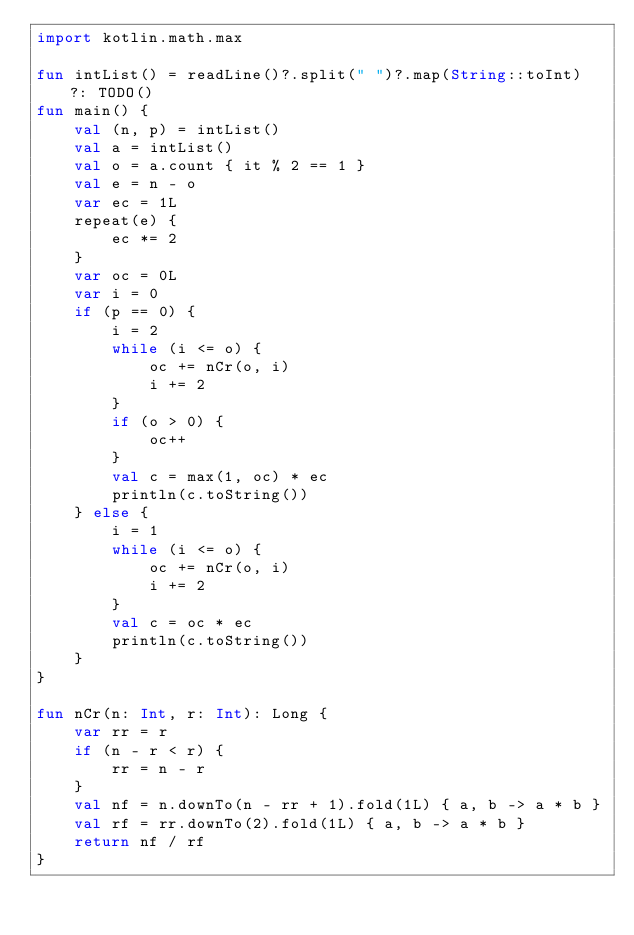Convert code to text. <code><loc_0><loc_0><loc_500><loc_500><_Kotlin_>import kotlin.math.max

fun intList() = readLine()?.split(" ")?.map(String::toInt) ?: TODO()
fun main() {
    val (n, p) = intList()
    val a = intList()
    val o = a.count { it % 2 == 1 }
    val e = n - o
    var ec = 1L
    repeat(e) {
        ec *= 2
    }
    var oc = 0L
    var i = 0
    if (p == 0) {
        i = 2
        while (i <= o) {
            oc += nCr(o, i)
            i += 2
        }
        if (o > 0) {
            oc++
        }
        val c = max(1, oc) * ec
        println(c.toString())
    } else {
        i = 1
        while (i <= o) {
            oc += nCr(o, i)
            i += 2
        }
        val c = oc * ec
        println(c.toString())
    }
}

fun nCr(n: Int, r: Int): Long {
    var rr = r
    if (n - r < r) {
        rr = n - r
    }
    val nf = n.downTo(n - rr + 1).fold(1L) { a, b -> a * b }
    val rf = rr.downTo(2).fold(1L) { a, b -> a * b }
    return nf / rf
}</code> 